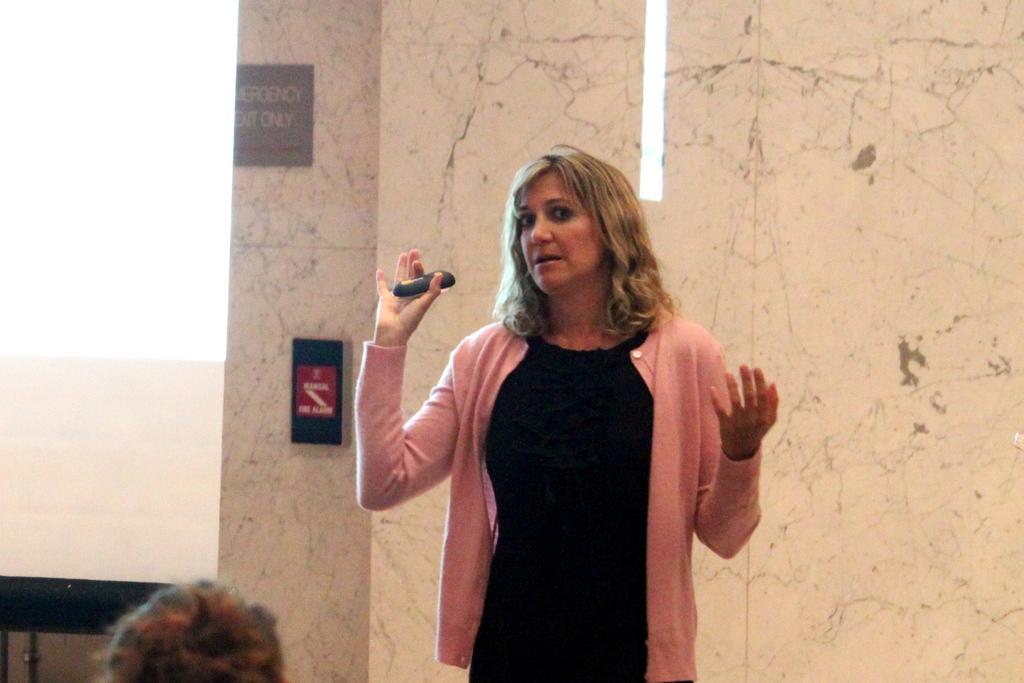Describe this image in one or two sentences. In this image we can see a woman is standing. She is wearing black color dress with pink shirt and holding black color thing in her hand. Behind her, wall and screen is there. At the bottom of the image, one person head is there. 